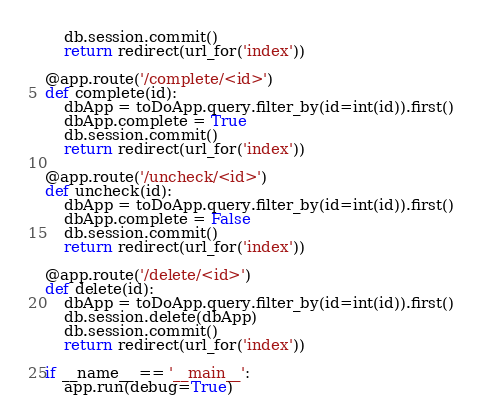Convert code to text. <code><loc_0><loc_0><loc_500><loc_500><_Python_>    db.session.commit()
    return redirect(url_for('index'))

@app.route('/complete/<id>')
def complete(id):
    dbApp = toDoApp.query.filter_by(id=int(id)).first()
    dbApp.complete = True
    db.session.commit()
    return redirect(url_for('index'))

@app.route('/uncheck/<id>')
def uncheck(id):
    dbApp = toDoApp.query.filter_by(id=int(id)).first()
    dbApp.complete = False
    db.session.commit()
    return redirect(url_for('index'))

@app.route('/delete/<id>')
def delete(id):
    dbApp = toDoApp.query.filter_by(id=int(id)).first()
    db.session.delete(dbApp)
    db.session.commit()
    return redirect(url_for('index'))

if __name__ == '__main__':
    app.run(debug=True)
</code> 